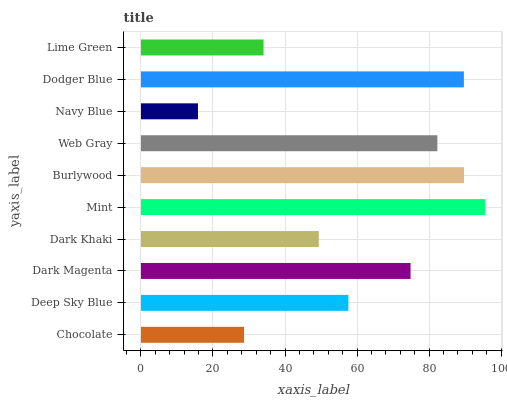Is Navy Blue the minimum?
Answer yes or no. Yes. Is Mint the maximum?
Answer yes or no. Yes. Is Deep Sky Blue the minimum?
Answer yes or no. No. Is Deep Sky Blue the maximum?
Answer yes or no. No. Is Deep Sky Blue greater than Chocolate?
Answer yes or no. Yes. Is Chocolate less than Deep Sky Blue?
Answer yes or no. Yes. Is Chocolate greater than Deep Sky Blue?
Answer yes or no. No. Is Deep Sky Blue less than Chocolate?
Answer yes or no. No. Is Dark Magenta the high median?
Answer yes or no. Yes. Is Deep Sky Blue the low median?
Answer yes or no. Yes. Is Dark Khaki the high median?
Answer yes or no. No. Is Burlywood the low median?
Answer yes or no. No. 